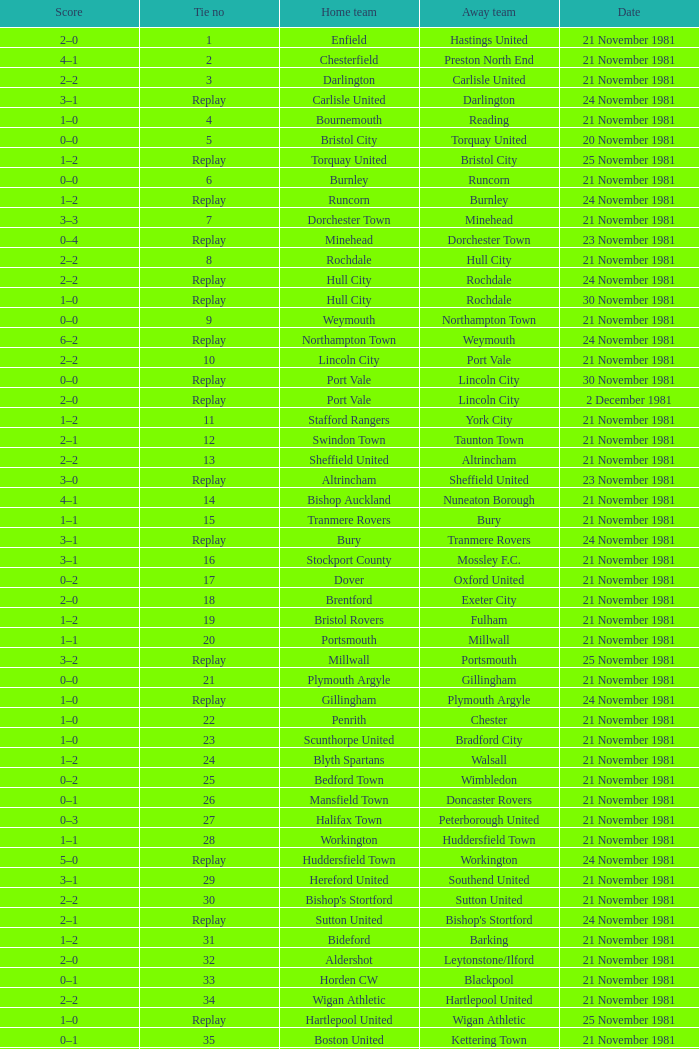Minehead has what tie number? Replay. Parse the table in full. {'header': ['Score', 'Tie no', 'Home team', 'Away team', 'Date'], 'rows': [['2–0', '1', 'Enfield', 'Hastings United', '21 November 1981'], ['4–1', '2', 'Chesterfield', 'Preston North End', '21 November 1981'], ['2–2', '3', 'Darlington', 'Carlisle United', '21 November 1981'], ['3–1', 'Replay', 'Carlisle United', 'Darlington', '24 November 1981'], ['1–0', '4', 'Bournemouth', 'Reading', '21 November 1981'], ['0–0', '5', 'Bristol City', 'Torquay United', '20 November 1981'], ['1–2', 'Replay', 'Torquay United', 'Bristol City', '25 November 1981'], ['0–0', '6', 'Burnley', 'Runcorn', '21 November 1981'], ['1–2', 'Replay', 'Runcorn', 'Burnley', '24 November 1981'], ['3–3', '7', 'Dorchester Town', 'Minehead', '21 November 1981'], ['0–4', 'Replay', 'Minehead', 'Dorchester Town', '23 November 1981'], ['2–2', '8', 'Rochdale', 'Hull City', '21 November 1981'], ['2–2', 'Replay', 'Hull City', 'Rochdale', '24 November 1981'], ['1–0', 'Replay', 'Hull City', 'Rochdale', '30 November 1981'], ['0–0', '9', 'Weymouth', 'Northampton Town', '21 November 1981'], ['6–2', 'Replay', 'Northampton Town', 'Weymouth', '24 November 1981'], ['2–2', '10', 'Lincoln City', 'Port Vale', '21 November 1981'], ['0–0', 'Replay', 'Port Vale', 'Lincoln City', '30 November 1981'], ['2–0', 'Replay', 'Port Vale', 'Lincoln City', '2 December 1981'], ['1–2', '11', 'Stafford Rangers', 'York City', '21 November 1981'], ['2–1', '12', 'Swindon Town', 'Taunton Town', '21 November 1981'], ['2–2', '13', 'Sheffield United', 'Altrincham', '21 November 1981'], ['3–0', 'Replay', 'Altrincham', 'Sheffield United', '23 November 1981'], ['4–1', '14', 'Bishop Auckland', 'Nuneaton Borough', '21 November 1981'], ['1–1', '15', 'Tranmere Rovers', 'Bury', '21 November 1981'], ['3–1', 'Replay', 'Bury', 'Tranmere Rovers', '24 November 1981'], ['3–1', '16', 'Stockport County', 'Mossley F.C.', '21 November 1981'], ['0–2', '17', 'Dover', 'Oxford United', '21 November 1981'], ['2–0', '18', 'Brentford', 'Exeter City', '21 November 1981'], ['1–2', '19', 'Bristol Rovers', 'Fulham', '21 November 1981'], ['1–1', '20', 'Portsmouth', 'Millwall', '21 November 1981'], ['3–2', 'Replay', 'Millwall', 'Portsmouth', '25 November 1981'], ['0–0', '21', 'Plymouth Argyle', 'Gillingham', '21 November 1981'], ['1–0', 'Replay', 'Gillingham', 'Plymouth Argyle', '24 November 1981'], ['1–0', '22', 'Penrith', 'Chester', '21 November 1981'], ['1–0', '23', 'Scunthorpe United', 'Bradford City', '21 November 1981'], ['1–2', '24', 'Blyth Spartans', 'Walsall', '21 November 1981'], ['0–2', '25', 'Bedford Town', 'Wimbledon', '21 November 1981'], ['0–1', '26', 'Mansfield Town', 'Doncaster Rovers', '21 November 1981'], ['0–3', '27', 'Halifax Town', 'Peterborough United', '21 November 1981'], ['1–1', '28', 'Workington', 'Huddersfield Town', '21 November 1981'], ['5–0', 'Replay', 'Huddersfield Town', 'Workington', '24 November 1981'], ['3–1', '29', 'Hereford United', 'Southend United', '21 November 1981'], ['2–2', '30', "Bishop's Stortford", 'Sutton United', '21 November 1981'], ['2–1', 'Replay', 'Sutton United', "Bishop's Stortford", '24 November 1981'], ['1–2', '31', 'Bideford', 'Barking', '21 November 1981'], ['2–0', '32', 'Aldershot', 'Leytonstone/Ilford', '21 November 1981'], ['0–1', '33', 'Horden CW', 'Blackpool', '21 November 1981'], ['2–2', '34', 'Wigan Athletic', 'Hartlepool United', '21 November 1981'], ['1–0', 'Replay', 'Hartlepool United', 'Wigan Athletic', '25 November 1981'], ['0–1', '35', 'Boston United', 'Kettering Town', '21 November 1981'], ['0–0', '36', 'Harlow Town', 'Barnet', '21 November 1981'], ['1–0', 'Replay', 'Barnet', 'Harlow Town', '24 November 1981'], ['2–0', '37', 'Colchester United', 'Newport County', '21 November 1981'], ['1–1', '38', 'Hendon', 'Wycombe Wanderers', '21 November 1981'], ['2–0', 'Replay', 'Wycombe Wanderers', 'Hendon', '24 November 1981'], ['2–2', '39', 'Dagenham', 'Yeovil Town', '21 November 1981'], ['0–1', 'Replay', 'Yeovil Town', 'Dagenham', '25 November 1981'], ['0–1', '40', 'Willenhall Town', 'Crewe Alexandra', '21 November 1981']]} 